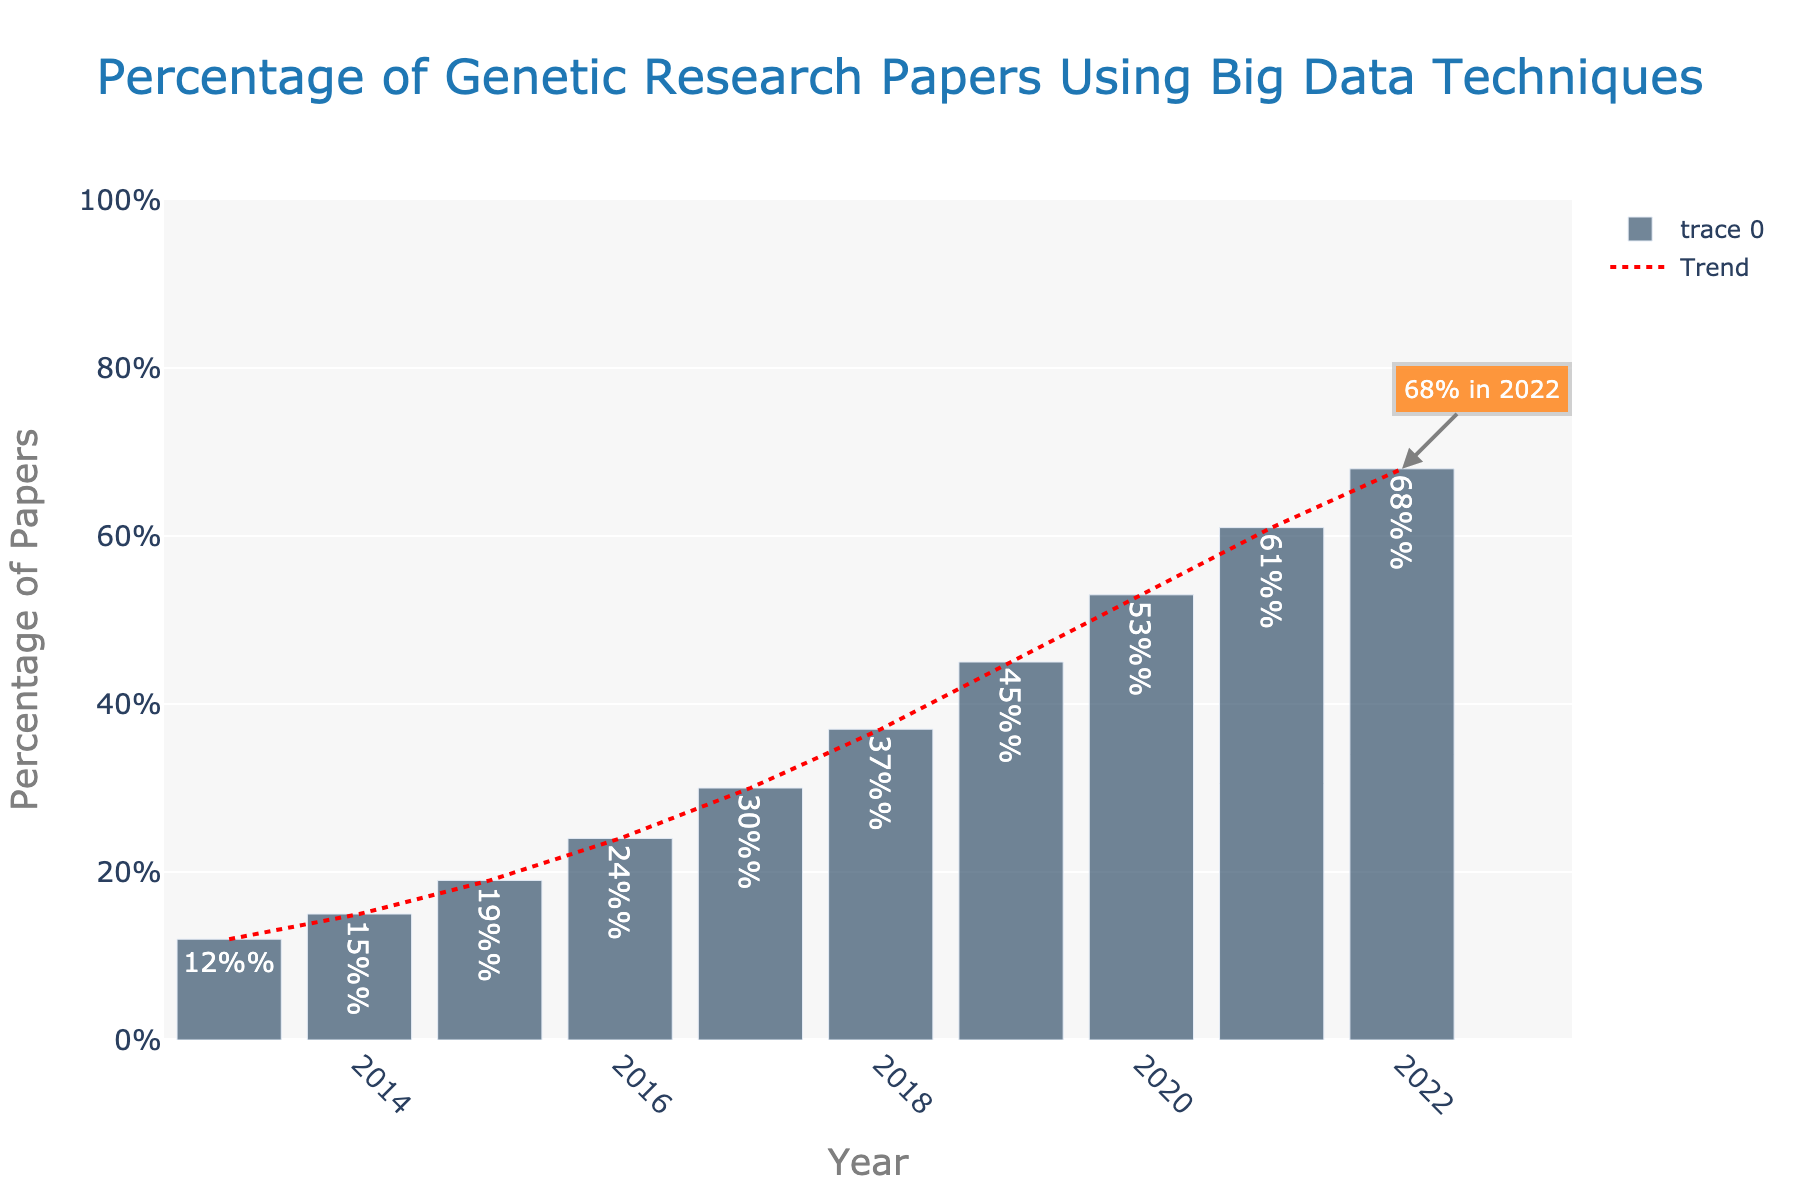What was the percentage of genetic research papers incorporating big data techniques in 2013? Look at the bar corresponding to the year 2013 on the bar chart. The label or height of the bar indicates the percentage.
Answer: 12% By how much did the percentage increase from 2013 to 2022? Subtract the percentage for 2013 from the percentage for 2022. Calculate 68% (2022) - 12% (2013).
Answer: 56% Which year saw the highest percentage of genetic research papers using big data techniques? Identify the bar with the maximum height by visually scanning the chart. The year label underneath this bar indicates the year.
Answer: 2022 During which year did the percentage surpass 50% for the first time? Locate the bars for each year visually and find the first instance where the bar height exceeds the 50% mark.
Answer: 2020 What is the average percentage of papers using big data techniques from 2018 to 2022? Add the percentages from 2018 to 2022 and divide by the number of years (5). Calculate (37% + 45% + 53% + 61% + 68%)/5.
Answer: 52.8% Is the trend in the percentage of papers using big data techniques increasing or decreasing? The trend line on the chart is almost consistently moving upward from left to right. This suggests an increasing trend.
Answer: Increasing What visual feature indicates the exact percentage value for 2022? A specific annotation on the chart with an arrow pointing to the bar for 2022 shows the exact value.
Answer: Annotation saying "68% in 2022" Between which consecutive years was the largest jump in the percentage observed? Compare the differences in percentages between consecutive years and identify the largest gap. Evaluate differences: 2014-2013, 2015-2014, ..., 2022-2021, find the maximum.
Answer: 2019-2020 By how much did the percentage increase from 2017 to 2018? Subtract the percentage for 2017 from the percentage for 2018. Calculate 37% (2018) - 30% (2017).
Answer: 7% Which bar is highlighted in the boldest color, and why? The bar for 2022 is highlighted with bold annotation and arrow callout, indicating its significance.
Answer: 2022 